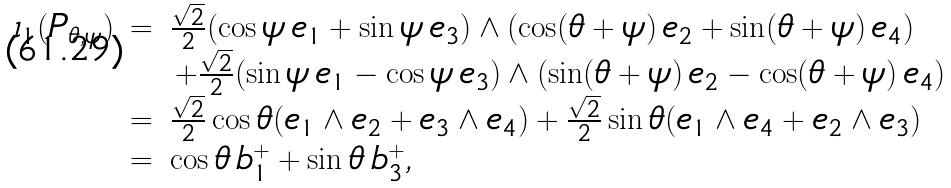<formula> <loc_0><loc_0><loc_500><loc_500>\begin{array} { l l l } \iota _ { 1 } ( P _ { \theta , \psi } ) & = & \frac { \sqrt { 2 } } { 2 } ( \cos \psi \, e _ { 1 } + \sin \psi \, e _ { 3 } ) \wedge ( \cos ( \theta + \psi ) \, e _ { 2 } + \sin ( \theta + \psi ) \, e _ { 4 } ) \\ & & \, + \frac { \sqrt { 2 } } { 2 } ( \sin \psi \, e _ { 1 } - \cos \psi \, e _ { 3 } ) \wedge ( \sin ( \theta + \psi ) \, e _ { 2 } - \cos ( \theta + \psi ) \, e _ { 4 } ) \\ & = & \frac { \sqrt { 2 } } { 2 } \cos \theta ( e _ { 1 } \wedge e _ { 2 } + e _ { 3 } \wedge e _ { 4 } ) + \frac { \sqrt { 2 } } { 2 } \sin \theta ( e _ { 1 } \wedge e _ { 4 } + e _ { 2 } \wedge e _ { 3 } ) \\ & = & \cos \theta \, b _ { 1 } ^ { + } + \sin \theta \, b _ { 3 } ^ { + } , \end{array}</formula> 